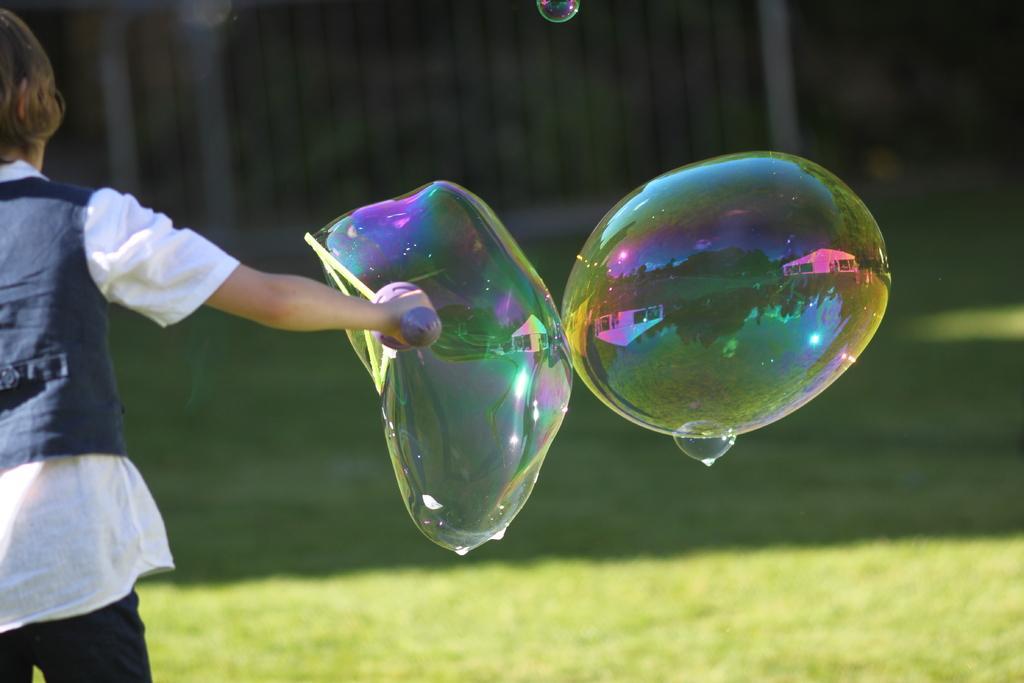Describe this image in one or two sentences. In this picture we can see a person holding a bubble stick. There are bubbles. On the bubble we can see the reflection of houses and trees. Here we can see grass. There is a dark background. 